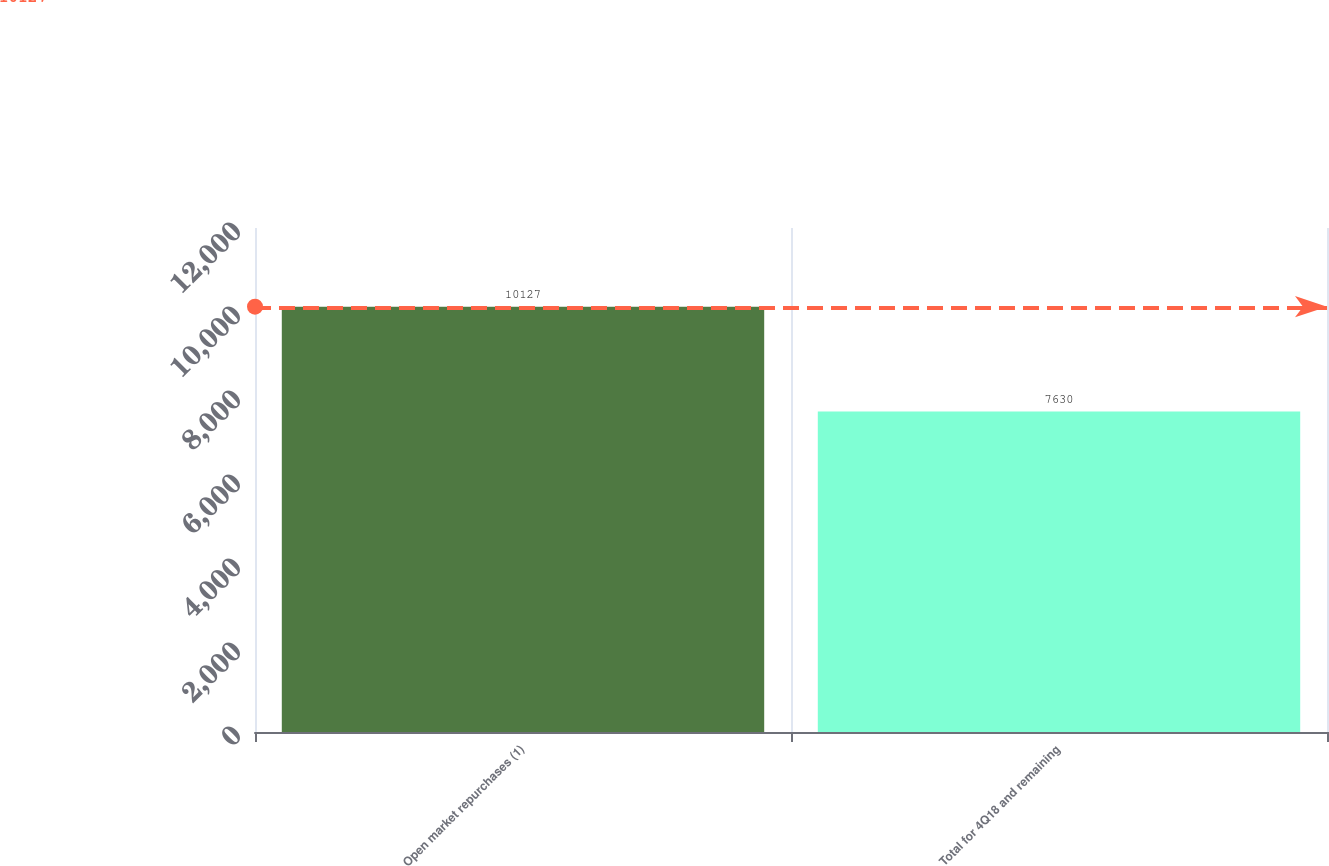<chart> <loc_0><loc_0><loc_500><loc_500><bar_chart><fcel>Open market repurchases (1)<fcel>Total for 4Q18 and remaining<nl><fcel>10127<fcel>7630<nl></chart> 